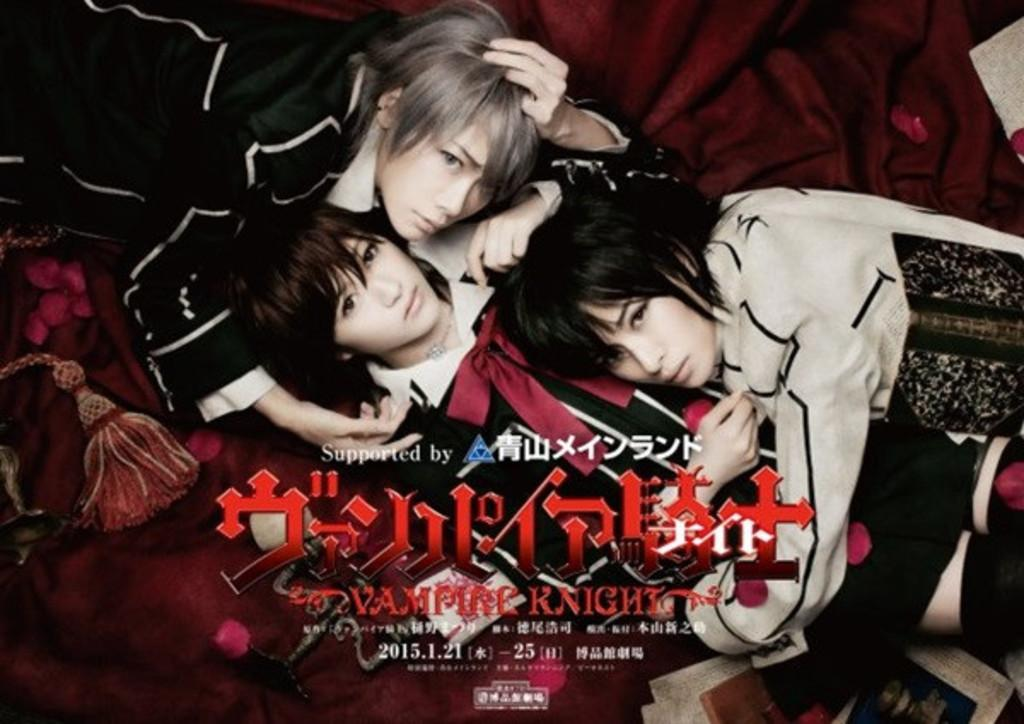What are the persons in the image doing? The persons in the image are lying down. Is there any text present in the image? Yes, there is text written on the image. Can you see any salt on the persons' stomachs in the image? There is no salt or stomachs visible in the image; it only shows persons lying down and text. 